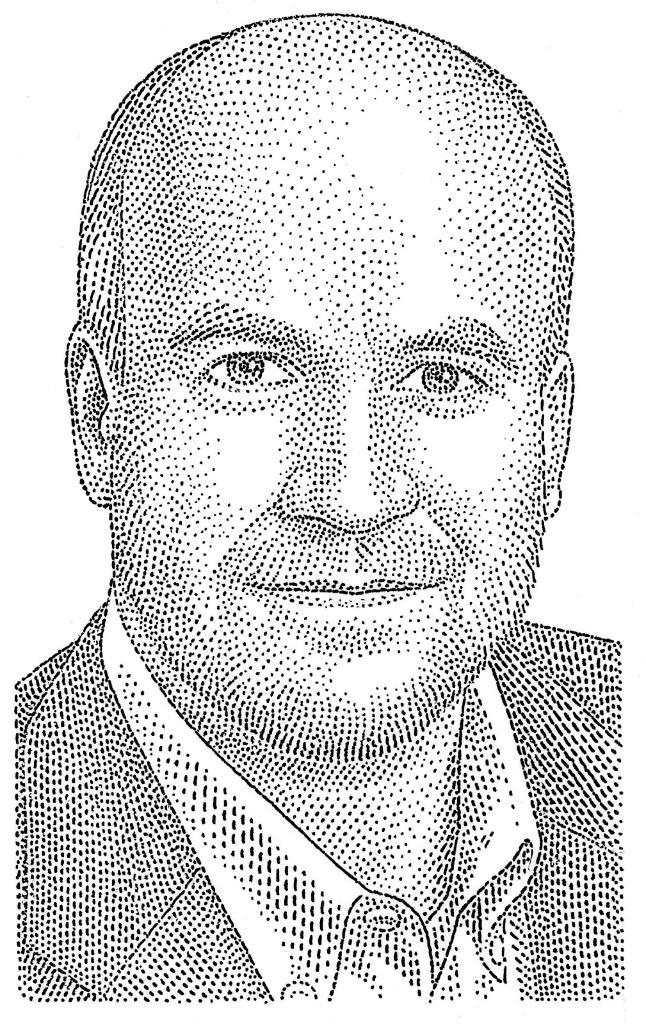What type of portrait is shown in the image? The image is a Dot portrait. Who is the subject of the portrait? The subject of the portrait is a man. What type of territory is being claimed by the man in the image? There is no indication of territory or any claim being made in the image, as it is a Dot portrait of a man. 